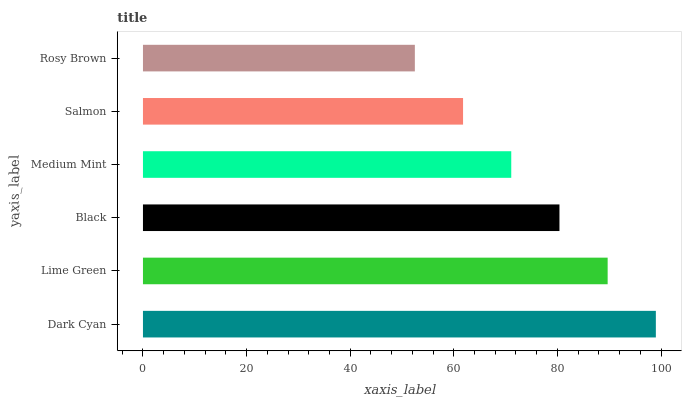Is Rosy Brown the minimum?
Answer yes or no. Yes. Is Dark Cyan the maximum?
Answer yes or no. Yes. Is Lime Green the minimum?
Answer yes or no. No. Is Lime Green the maximum?
Answer yes or no. No. Is Dark Cyan greater than Lime Green?
Answer yes or no. Yes. Is Lime Green less than Dark Cyan?
Answer yes or no. Yes. Is Lime Green greater than Dark Cyan?
Answer yes or no. No. Is Dark Cyan less than Lime Green?
Answer yes or no. No. Is Black the high median?
Answer yes or no. Yes. Is Medium Mint the low median?
Answer yes or no. Yes. Is Dark Cyan the high median?
Answer yes or no. No. Is Salmon the low median?
Answer yes or no. No. 